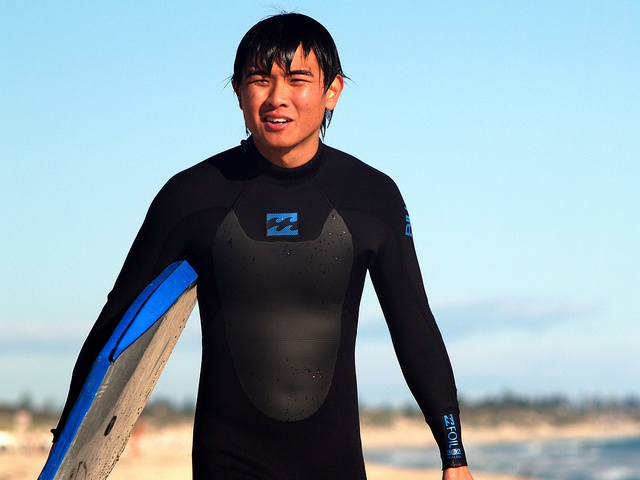Describe the objects in this image and their specific colors. I can see people in lightblue, black, maroon, and salmon tones and surfboard in lightblue, gray, blue, and tan tones in this image. 